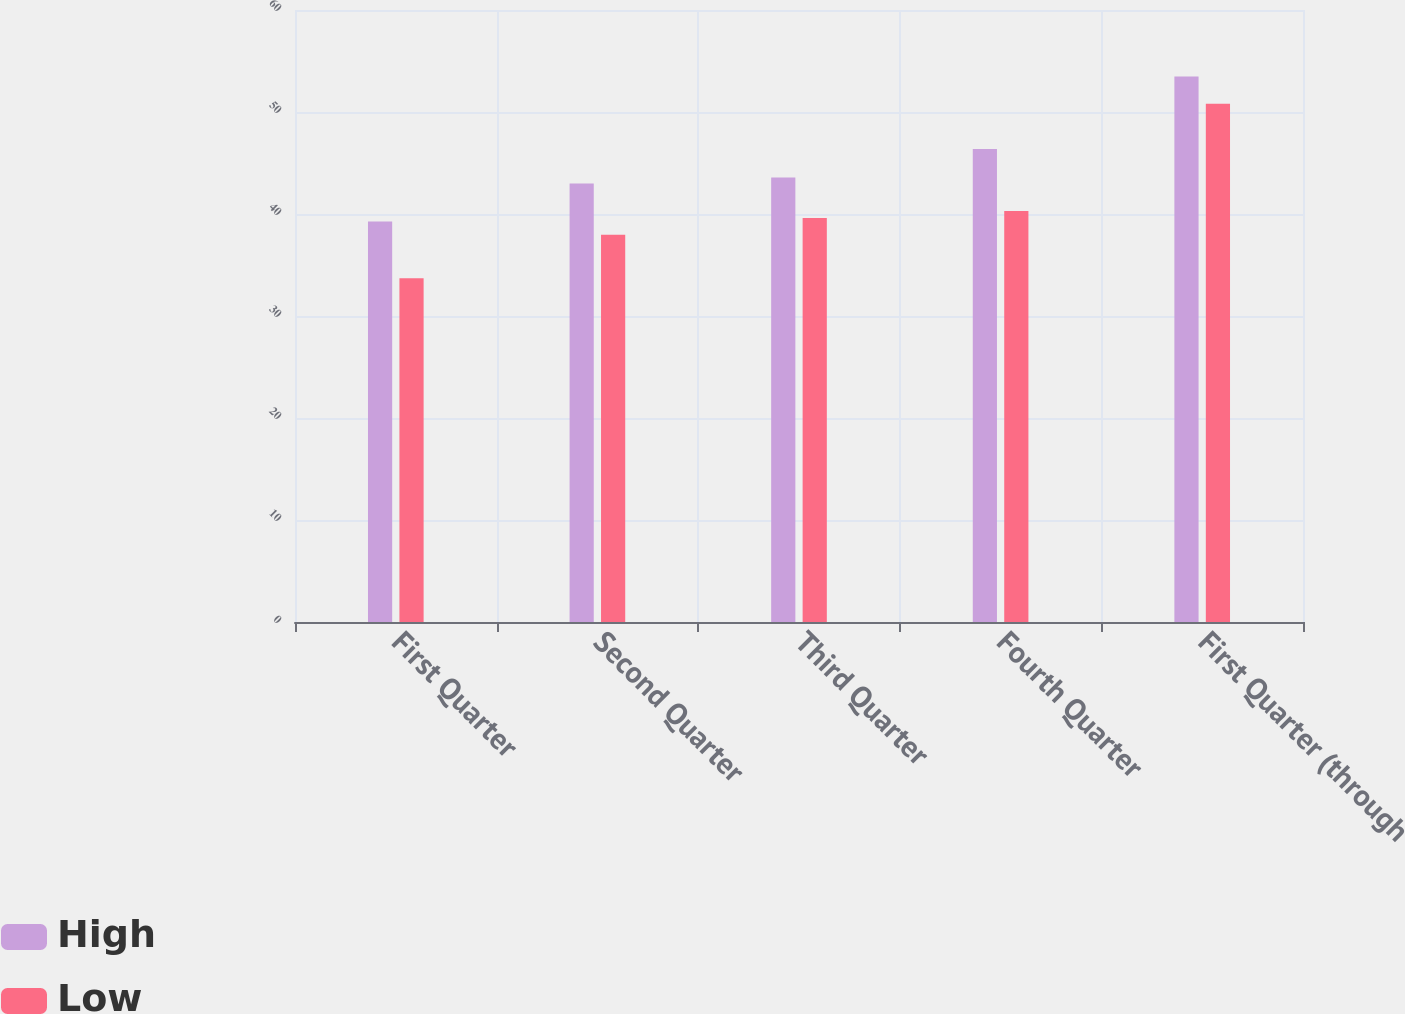<chart> <loc_0><loc_0><loc_500><loc_500><stacked_bar_chart><ecel><fcel>First Quarter<fcel>Second Quarter<fcel>Third Quarter<fcel>Fourth Quarter<fcel>First Quarter (through<nl><fcel>High<fcel>39.26<fcel>42.99<fcel>43.58<fcel>46.37<fcel>53.49<nl><fcel>Low<fcel>33.7<fcel>37.97<fcel>39.6<fcel>40.29<fcel>50.82<nl></chart> 